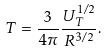Convert formula to latex. <formula><loc_0><loc_0><loc_500><loc_500>T = \frac { 3 } { 4 \pi } \frac { U _ { T } ^ { 1 / 2 } } { R ^ { 3 / 2 } } .</formula> 